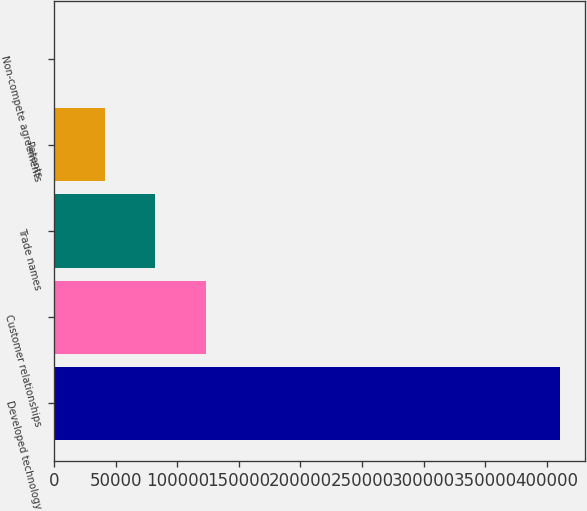<chart> <loc_0><loc_0><loc_500><loc_500><bar_chart><fcel>Developed technology<fcel>Customer relationships<fcel>Trade names<fcel>Patents<fcel>Non-compete agreements<nl><fcel>410801<fcel>123250<fcel>82171.4<fcel>41092.7<fcel>14<nl></chart> 